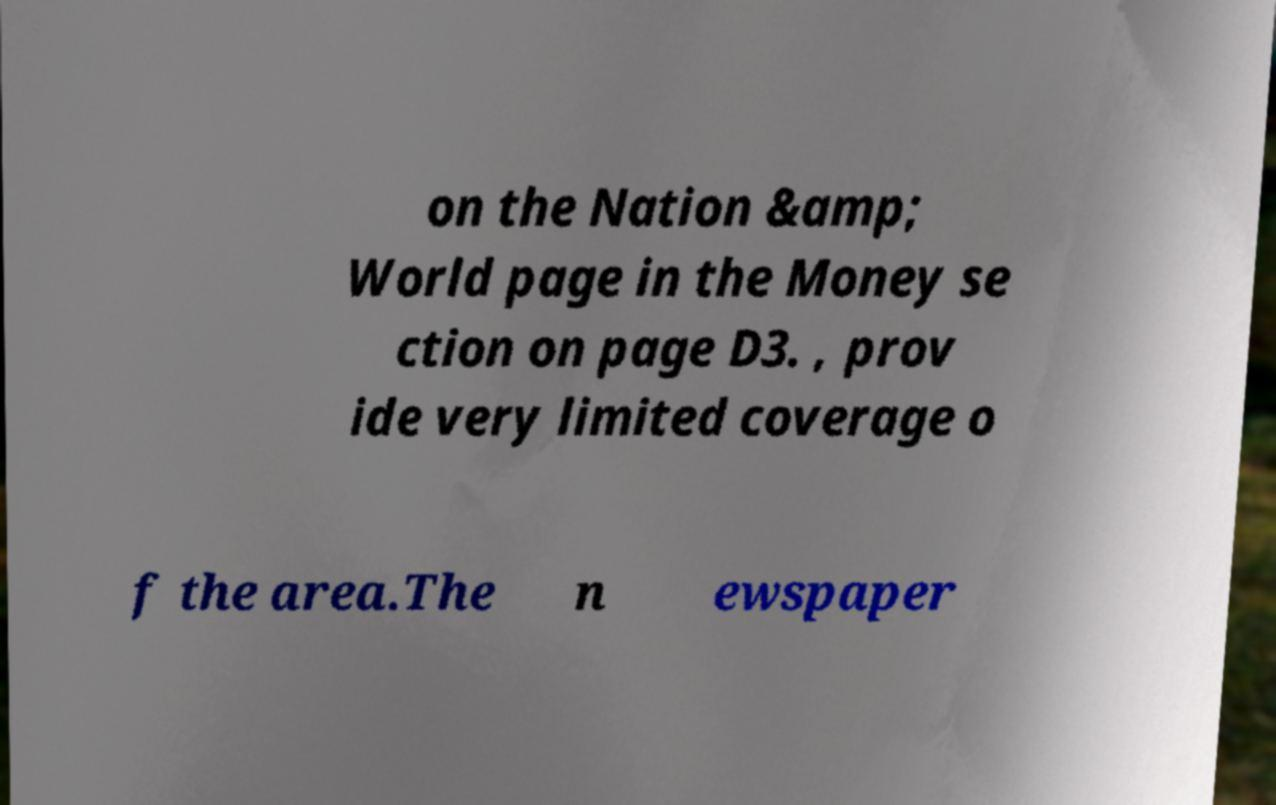Could you assist in decoding the text presented in this image and type it out clearly? on the Nation &amp; World page in the Money se ction on page D3. , prov ide very limited coverage o f the area.The n ewspaper 